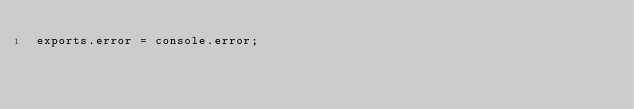Convert code to text. <code><loc_0><loc_0><loc_500><loc_500><_JavaScript_>exports.error = console.error;</code> 